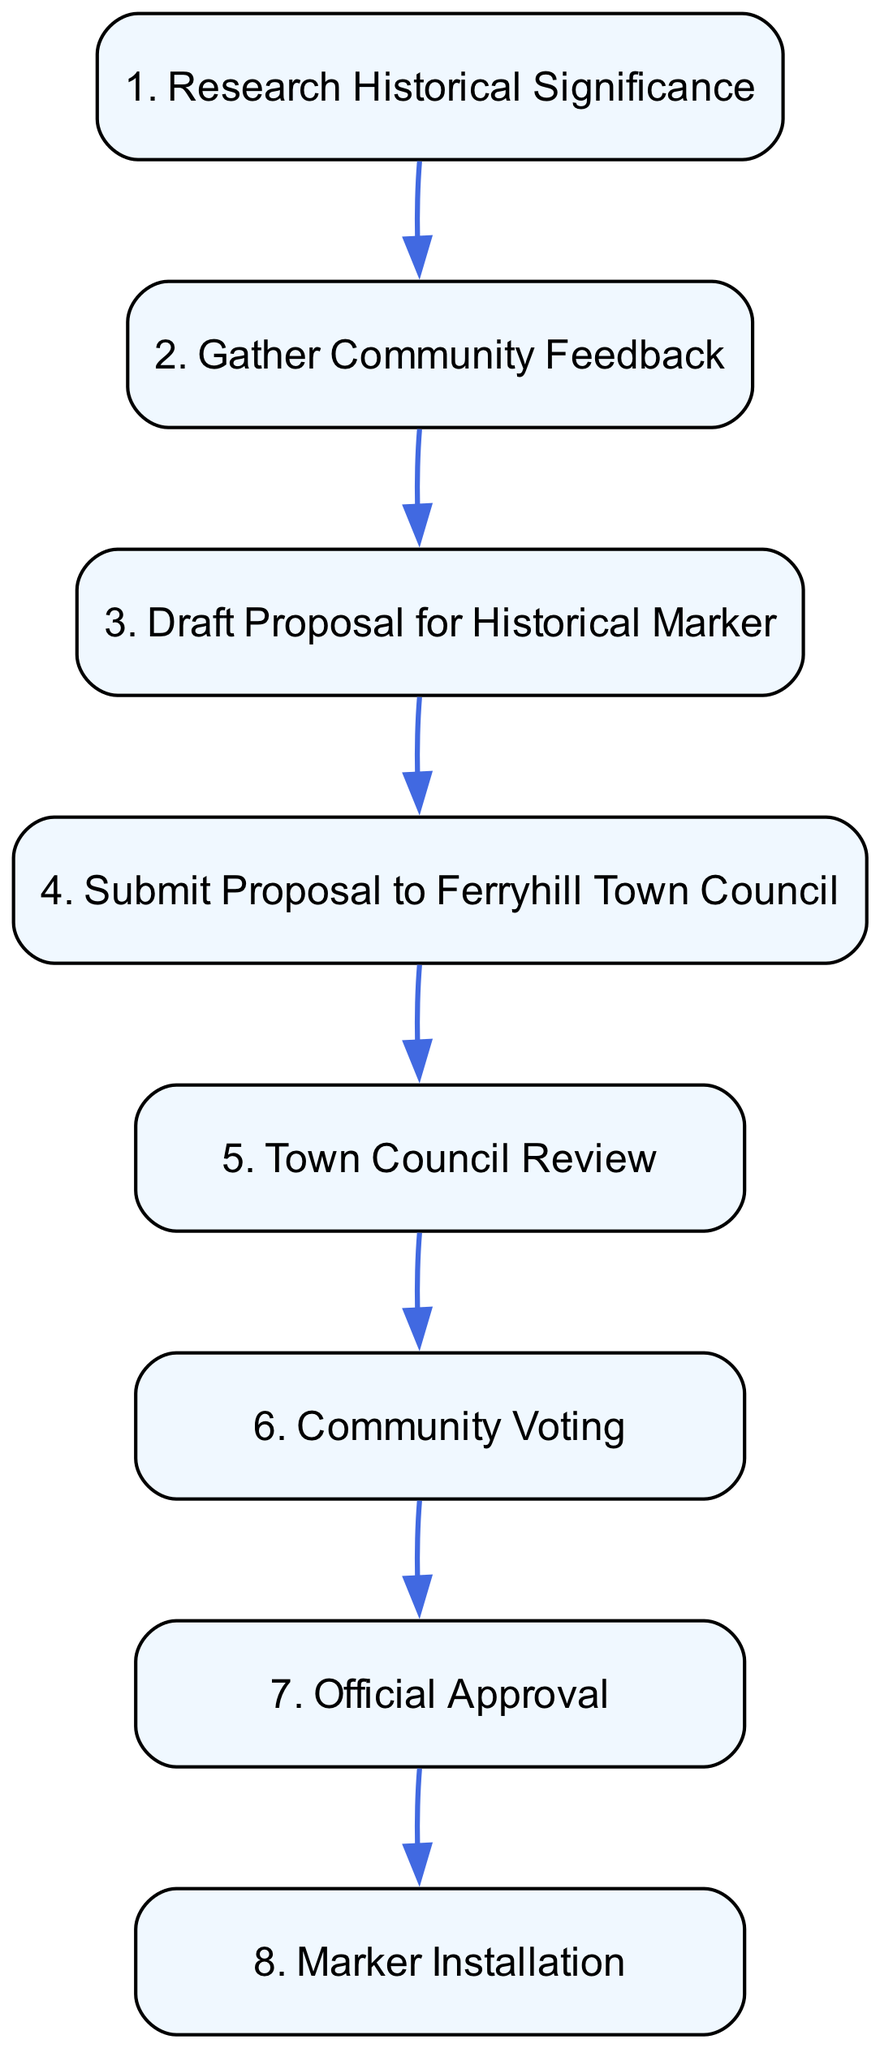What is the first step in the process? The first step in the diagram is "Research Historical Significance," which clearly shows that this is where the process begins, indicating the initial action the resident takes.
Answer: Research Historical Significance How many steps are there in total? By counting each step listed in the diagram, there are eight distinct actions or steps that the resident follows to propose the historical marker.
Answer: Eight What follows after "Gather Community Feedback"? Based on the flow of the diagram, after "Gather Community Feedback," the resident proceeds to "Draft Proposal for Historical Marker," which outlines the next action in the sequence.
Answer: Draft Proposal for Historical Marker Which step involves the Ferryhill Town Council? The steps that involve the Ferryhill Town Council are "Submit Proposal to Ferryhill Town Council," "Town Council Review," and "Official Approval." These steps collectively show the council's role in the proposal process.
Answer: Submit Proposal to Ferryhill Town Council, Town Council Review, Official Approval What is required before the "Marker Installation"? Before the "Marker Installation," the step "Official Approval" is necessary, as it indicates that the proposal must be formally accepted and funded by the Town Council, allowing for the installation to take place.
Answer: Official Approval What step is directly after the community vote? The step that follows directly after "Community Voting" is "Official Approval." This indicates that the community's vote influences the council's final approval of the proposal.
Answer: Official Approval What is the last action taken in this sequence? The final action in the diagram is "Marker Installation," which signifies the completion of the process after all prior steps have been executed and approved.
Answer: Marker Installation How does community involvement occur in this process? Community involvement occurs during the "Gather Community Feedback" and "Community Voting" steps. These stages show how the resident actively seeks input and support from local residents before a decision is made.
Answer: Gather Community Feedback, Community Voting 